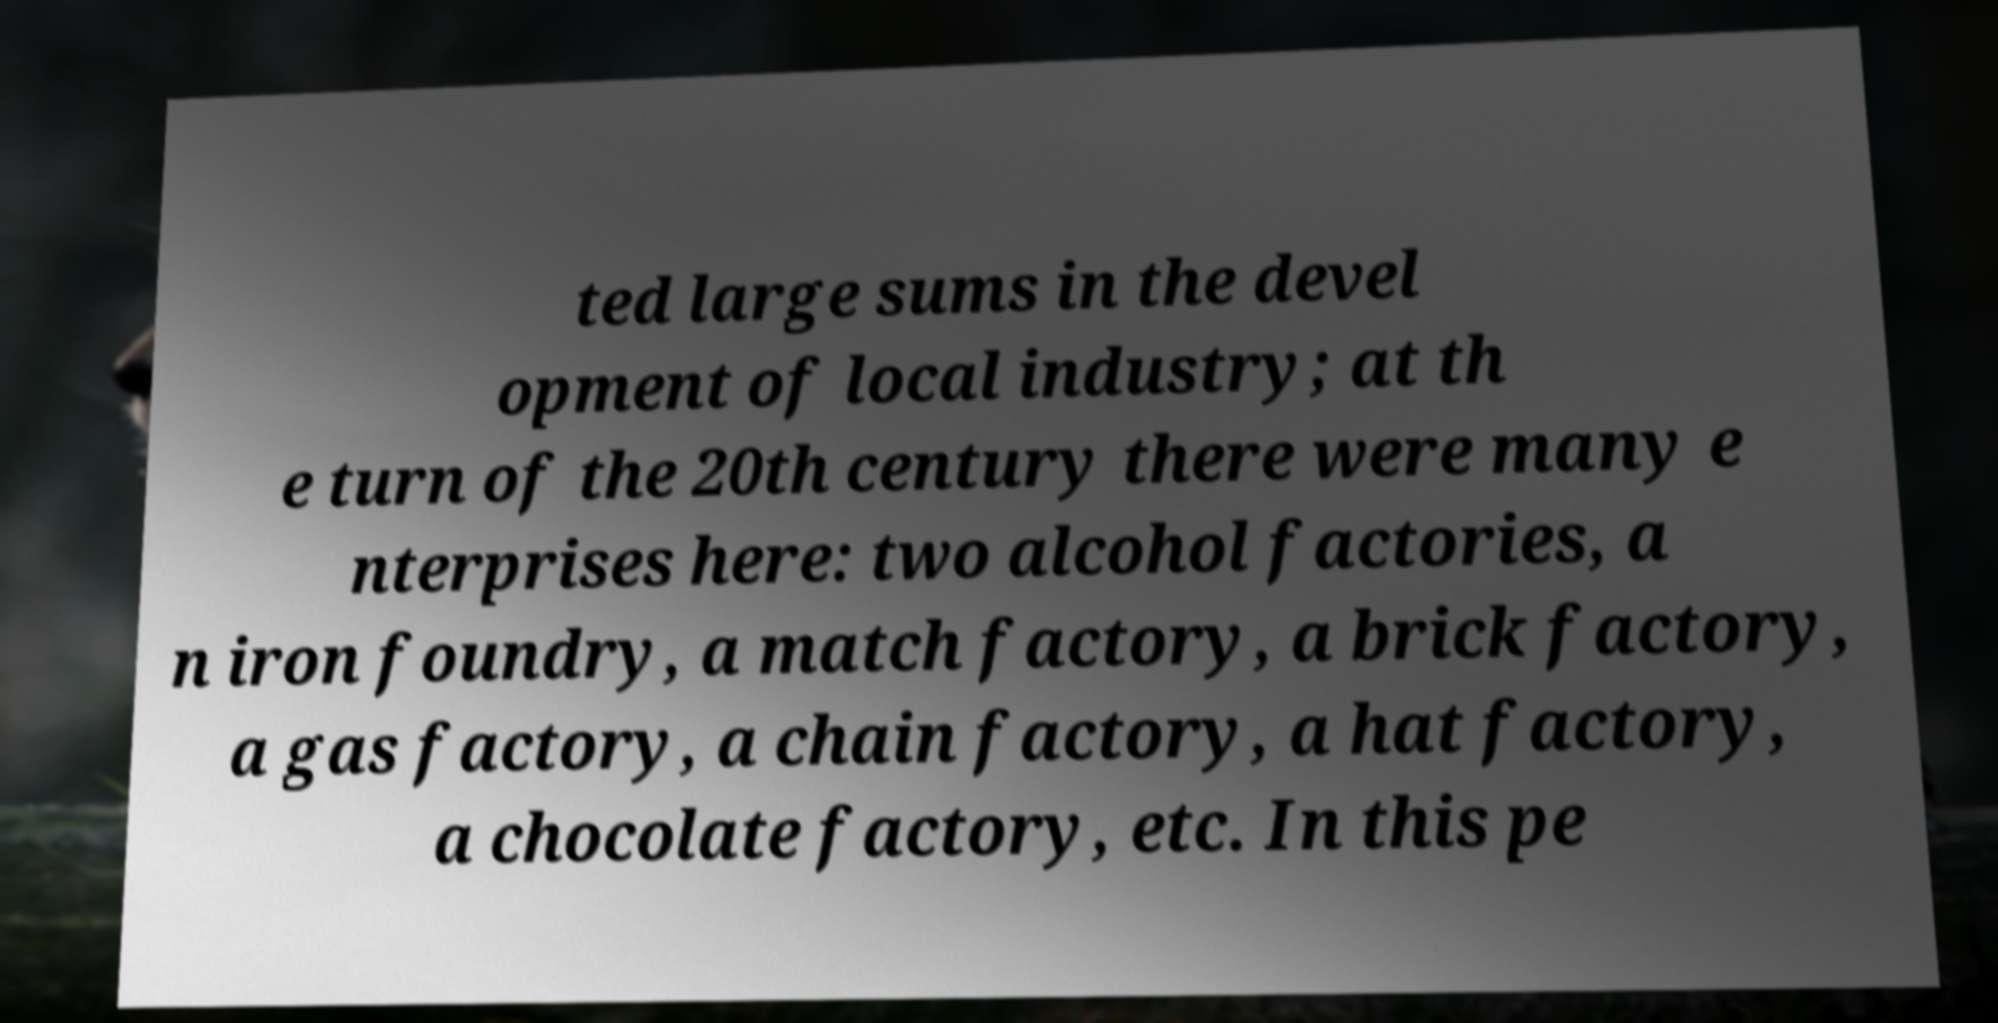Please read and relay the text visible in this image. What does it say? ted large sums in the devel opment of local industry; at th e turn of the 20th century there were many e nterprises here: two alcohol factories, a n iron foundry, a match factory, a brick factory, a gas factory, a chain factory, a hat factory, a chocolate factory, etc. In this pe 